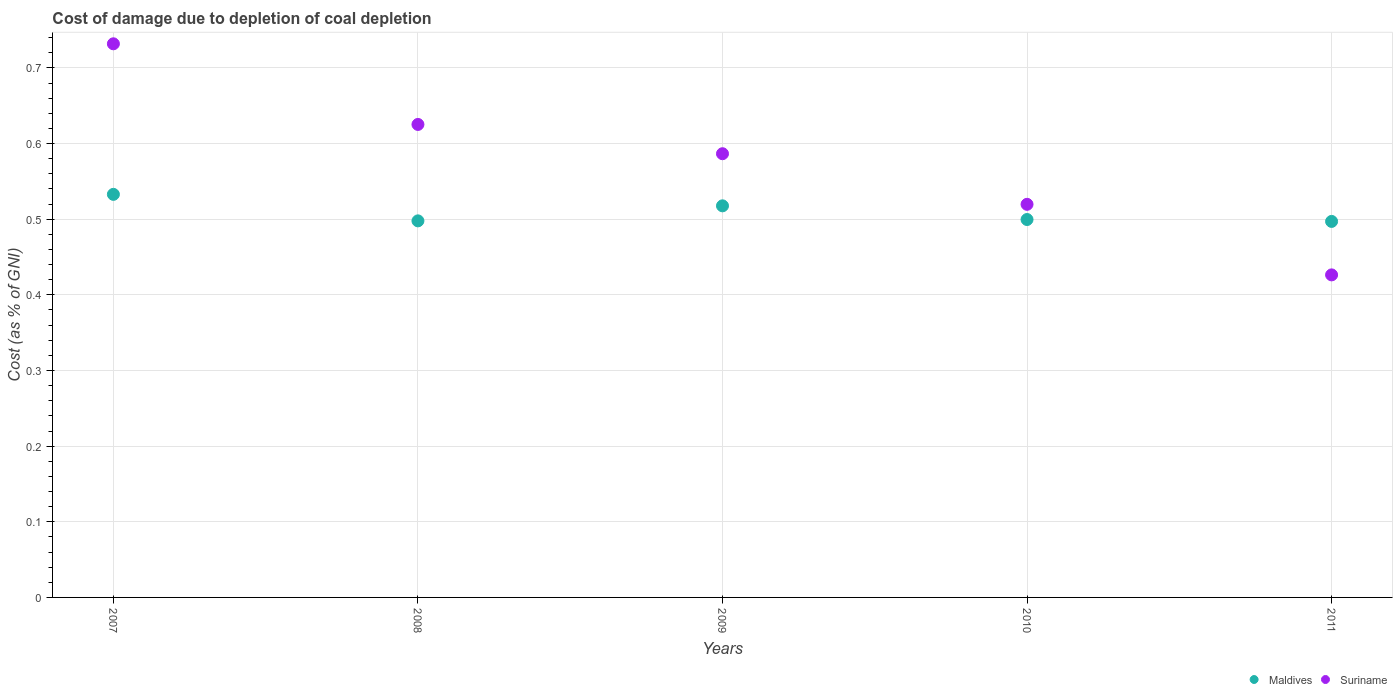How many different coloured dotlines are there?
Your answer should be very brief. 2. Is the number of dotlines equal to the number of legend labels?
Your response must be concise. Yes. What is the cost of damage caused due to coal depletion in Maldives in 2009?
Provide a short and direct response. 0.52. Across all years, what is the maximum cost of damage caused due to coal depletion in Maldives?
Provide a short and direct response. 0.53. Across all years, what is the minimum cost of damage caused due to coal depletion in Suriname?
Keep it short and to the point. 0.43. In which year was the cost of damage caused due to coal depletion in Suriname maximum?
Your response must be concise. 2007. In which year was the cost of damage caused due to coal depletion in Suriname minimum?
Offer a very short reply. 2011. What is the total cost of damage caused due to coal depletion in Suriname in the graph?
Make the answer very short. 2.89. What is the difference between the cost of damage caused due to coal depletion in Suriname in 2009 and that in 2010?
Offer a very short reply. 0.07. What is the difference between the cost of damage caused due to coal depletion in Suriname in 2011 and the cost of damage caused due to coal depletion in Maldives in 2007?
Give a very brief answer. -0.11. What is the average cost of damage caused due to coal depletion in Maldives per year?
Offer a very short reply. 0.51. In the year 2008, what is the difference between the cost of damage caused due to coal depletion in Maldives and cost of damage caused due to coal depletion in Suriname?
Provide a succinct answer. -0.13. What is the ratio of the cost of damage caused due to coal depletion in Suriname in 2008 to that in 2010?
Make the answer very short. 1.2. Is the difference between the cost of damage caused due to coal depletion in Maldives in 2010 and 2011 greater than the difference between the cost of damage caused due to coal depletion in Suriname in 2010 and 2011?
Provide a short and direct response. No. What is the difference between the highest and the second highest cost of damage caused due to coal depletion in Suriname?
Ensure brevity in your answer.  0.11. What is the difference between the highest and the lowest cost of damage caused due to coal depletion in Maldives?
Your answer should be compact. 0.04. Is the sum of the cost of damage caused due to coal depletion in Maldives in 2008 and 2011 greater than the maximum cost of damage caused due to coal depletion in Suriname across all years?
Offer a terse response. Yes. How many dotlines are there?
Ensure brevity in your answer.  2. What is the difference between two consecutive major ticks on the Y-axis?
Your answer should be compact. 0.1. What is the title of the graph?
Your answer should be compact. Cost of damage due to depletion of coal depletion. What is the label or title of the X-axis?
Your answer should be very brief. Years. What is the label or title of the Y-axis?
Your response must be concise. Cost (as % of GNI). What is the Cost (as % of GNI) in Maldives in 2007?
Give a very brief answer. 0.53. What is the Cost (as % of GNI) of Suriname in 2007?
Your answer should be compact. 0.73. What is the Cost (as % of GNI) in Maldives in 2008?
Offer a very short reply. 0.5. What is the Cost (as % of GNI) in Suriname in 2008?
Your answer should be compact. 0.63. What is the Cost (as % of GNI) in Maldives in 2009?
Offer a terse response. 0.52. What is the Cost (as % of GNI) of Suriname in 2009?
Give a very brief answer. 0.59. What is the Cost (as % of GNI) in Maldives in 2010?
Provide a short and direct response. 0.5. What is the Cost (as % of GNI) in Suriname in 2010?
Provide a short and direct response. 0.52. What is the Cost (as % of GNI) in Maldives in 2011?
Offer a very short reply. 0.5. What is the Cost (as % of GNI) of Suriname in 2011?
Give a very brief answer. 0.43. Across all years, what is the maximum Cost (as % of GNI) in Maldives?
Make the answer very short. 0.53. Across all years, what is the maximum Cost (as % of GNI) in Suriname?
Give a very brief answer. 0.73. Across all years, what is the minimum Cost (as % of GNI) of Maldives?
Your answer should be compact. 0.5. Across all years, what is the minimum Cost (as % of GNI) of Suriname?
Keep it short and to the point. 0.43. What is the total Cost (as % of GNI) of Maldives in the graph?
Make the answer very short. 2.54. What is the total Cost (as % of GNI) of Suriname in the graph?
Ensure brevity in your answer.  2.89. What is the difference between the Cost (as % of GNI) of Maldives in 2007 and that in 2008?
Your response must be concise. 0.04. What is the difference between the Cost (as % of GNI) in Suriname in 2007 and that in 2008?
Your response must be concise. 0.11. What is the difference between the Cost (as % of GNI) of Maldives in 2007 and that in 2009?
Offer a very short reply. 0.02. What is the difference between the Cost (as % of GNI) in Suriname in 2007 and that in 2009?
Give a very brief answer. 0.15. What is the difference between the Cost (as % of GNI) in Suriname in 2007 and that in 2010?
Offer a very short reply. 0.21. What is the difference between the Cost (as % of GNI) in Maldives in 2007 and that in 2011?
Provide a short and direct response. 0.04. What is the difference between the Cost (as % of GNI) of Suriname in 2007 and that in 2011?
Provide a short and direct response. 0.31. What is the difference between the Cost (as % of GNI) in Maldives in 2008 and that in 2009?
Keep it short and to the point. -0.02. What is the difference between the Cost (as % of GNI) of Suriname in 2008 and that in 2009?
Give a very brief answer. 0.04. What is the difference between the Cost (as % of GNI) in Maldives in 2008 and that in 2010?
Your answer should be compact. -0. What is the difference between the Cost (as % of GNI) in Suriname in 2008 and that in 2010?
Keep it short and to the point. 0.11. What is the difference between the Cost (as % of GNI) of Maldives in 2008 and that in 2011?
Ensure brevity in your answer.  0. What is the difference between the Cost (as % of GNI) of Suriname in 2008 and that in 2011?
Provide a short and direct response. 0.2. What is the difference between the Cost (as % of GNI) in Maldives in 2009 and that in 2010?
Provide a succinct answer. 0.02. What is the difference between the Cost (as % of GNI) of Suriname in 2009 and that in 2010?
Your response must be concise. 0.07. What is the difference between the Cost (as % of GNI) of Maldives in 2009 and that in 2011?
Give a very brief answer. 0.02. What is the difference between the Cost (as % of GNI) in Suriname in 2009 and that in 2011?
Ensure brevity in your answer.  0.16. What is the difference between the Cost (as % of GNI) in Maldives in 2010 and that in 2011?
Your answer should be very brief. 0. What is the difference between the Cost (as % of GNI) of Suriname in 2010 and that in 2011?
Your answer should be compact. 0.09. What is the difference between the Cost (as % of GNI) of Maldives in 2007 and the Cost (as % of GNI) of Suriname in 2008?
Provide a succinct answer. -0.09. What is the difference between the Cost (as % of GNI) of Maldives in 2007 and the Cost (as % of GNI) of Suriname in 2009?
Provide a succinct answer. -0.05. What is the difference between the Cost (as % of GNI) of Maldives in 2007 and the Cost (as % of GNI) of Suriname in 2010?
Offer a very short reply. 0.01. What is the difference between the Cost (as % of GNI) of Maldives in 2007 and the Cost (as % of GNI) of Suriname in 2011?
Provide a short and direct response. 0.11. What is the difference between the Cost (as % of GNI) in Maldives in 2008 and the Cost (as % of GNI) in Suriname in 2009?
Your answer should be compact. -0.09. What is the difference between the Cost (as % of GNI) of Maldives in 2008 and the Cost (as % of GNI) of Suriname in 2010?
Your answer should be very brief. -0.02. What is the difference between the Cost (as % of GNI) of Maldives in 2008 and the Cost (as % of GNI) of Suriname in 2011?
Offer a very short reply. 0.07. What is the difference between the Cost (as % of GNI) of Maldives in 2009 and the Cost (as % of GNI) of Suriname in 2010?
Keep it short and to the point. -0. What is the difference between the Cost (as % of GNI) of Maldives in 2009 and the Cost (as % of GNI) of Suriname in 2011?
Give a very brief answer. 0.09. What is the difference between the Cost (as % of GNI) of Maldives in 2010 and the Cost (as % of GNI) of Suriname in 2011?
Offer a very short reply. 0.07. What is the average Cost (as % of GNI) of Maldives per year?
Your answer should be compact. 0.51. What is the average Cost (as % of GNI) in Suriname per year?
Provide a short and direct response. 0.58. In the year 2007, what is the difference between the Cost (as % of GNI) of Maldives and Cost (as % of GNI) of Suriname?
Your answer should be compact. -0.2. In the year 2008, what is the difference between the Cost (as % of GNI) in Maldives and Cost (as % of GNI) in Suriname?
Keep it short and to the point. -0.13. In the year 2009, what is the difference between the Cost (as % of GNI) in Maldives and Cost (as % of GNI) in Suriname?
Your answer should be very brief. -0.07. In the year 2010, what is the difference between the Cost (as % of GNI) of Maldives and Cost (as % of GNI) of Suriname?
Provide a short and direct response. -0.02. In the year 2011, what is the difference between the Cost (as % of GNI) of Maldives and Cost (as % of GNI) of Suriname?
Keep it short and to the point. 0.07. What is the ratio of the Cost (as % of GNI) in Maldives in 2007 to that in 2008?
Offer a terse response. 1.07. What is the ratio of the Cost (as % of GNI) in Suriname in 2007 to that in 2008?
Your answer should be compact. 1.17. What is the ratio of the Cost (as % of GNI) in Maldives in 2007 to that in 2009?
Your answer should be very brief. 1.03. What is the ratio of the Cost (as % of GNI) of Suriname in 2007 to that in 2009?
Provide a short and direct response. 1.25. What is the ratio of the Cost (as % of GNI) of Maldives in 2007 to that in 2010?
Your response must be concise. 1.07. What is the ratio of the Cost (as % of GNI) of Suriname in 2007 to that in 2010?
Offer a terse response. 1.41. What is the ratio of the Cost (as % of GNI) in Maldives in 2007 to that in 2011?
Ensure brevity in your answer.  1.07. What is the ratio of the Cost (as % of GNI) of Suriname in 2007 to that in 2011?
Give a very brief answer. 1.72. What is the ratio of the Cost (as % of GNI) in Maldives in 2008 to that in 2009?
Provide a succinct answer. 0.96. What is the ratio of the Cost (as % of GNI) in Suriname in 2008 to that in 2009?
Ensure brevity in your answer.  1.07. What is the ratio of the Cost (as % of GNI) of Maldives in 2008 to that in 2010?
Give a very brief answer. 1. What is the ratio of the Cost (as % of GNI) of Suriname in 2008 to that in 2010?
Ensure brevity in your answer.  1.2. What is the ratio of the Cost (as % of GNI) in Maldives in 2008 to that in 2011?
Your answer should be compact. 1. What is the ratio of the Cost (as % of GNI) in Suriname in 2008 to that in 2011?
Provide a succinct answer. 1.47. What is the ratio of the Cost (as % of GNI) in Maldives in 2009 to that in 2010?
Provide a succinct answer. 1.04. What is the ratio of the Cost (as % of GNI) in Suriname in 2009 to that in 2010?
Make the answer very short. 1.13. What is the ratio of the Cost (as % of GNI) of Maldives in 2009 to that in 2011?
Provide a succinct answer. 1.04. What is the ratio of the Cost (as % of GNI) in Suriname in 2009 to that in 2011?
Make the answer very short. 1.38. What is the ratio of the Cost (as % of GNI) in Maldives in 2010 to that in 2011?
Your response must be concise. 1. What is the ratio of the Cost (as % of GNI) in Suriname in 2010 to that in 2011?
Your response must be concise. 1.22. What is the difference between the highest and the second highest Cost (as % of GNI) of Maldives?
Provide a succinct answer. 0.02. What is the difference between the highest and the second highest Cost (as % of GNI) of Suriname?
Make the answer very short. 0.11. What is the difference between the highest and the lowest Cost (as % of GNI) in Maldives?
Your answer should be compact. 0.04. What is the difference between the highest and the lowest Cost (as % of GNI) in Suriname?
Offer a very short reply. 0.31. 